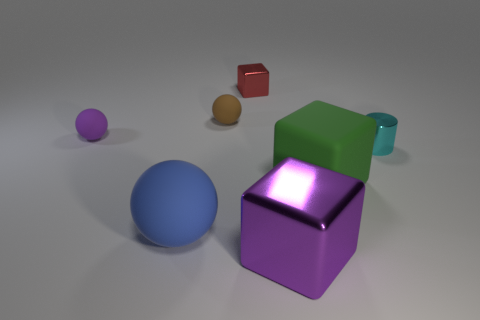Are there any other things that have the same shape as the tiny cyan shiny thing?
Provide a succinct answer. No. There is a metal object behind the tiny purple rubber thing; does it have the same shape as the large object that is behind the large ball?
Give a very brief answer. Yes. There is a brown matte object; does it have the same size as the purple object that is on the left side of the blue object?
Keep it short and to the point. Yes. Is the number of large blue shiny balls greater than the number of blue matte balls?
Your answer should be compact. No. Do the thing in front of the large blue thing and the block on the right side of the purple metallic cube have the same material?
Your response must be concise. No. What is the material of the green cube?
Give a very brief answer. Rubber. Is the number of purple matte objects that are in front of the big blue object greater than the number of big blue rubber balls?
Keep it short and to the point. No. What number of tiny purple balls are to the right of the big blue rubber ball that is left of the matte thing that is right of the red shiny object?
Give a very brief answer. 0. What is the material of the cube that is both in front of the tiny cyan shiny cylinder and on the left side of the large green rubber cube?
Make the answer very short. Metal. The cylinder has what color?
Offer a terse response. Cyan. 